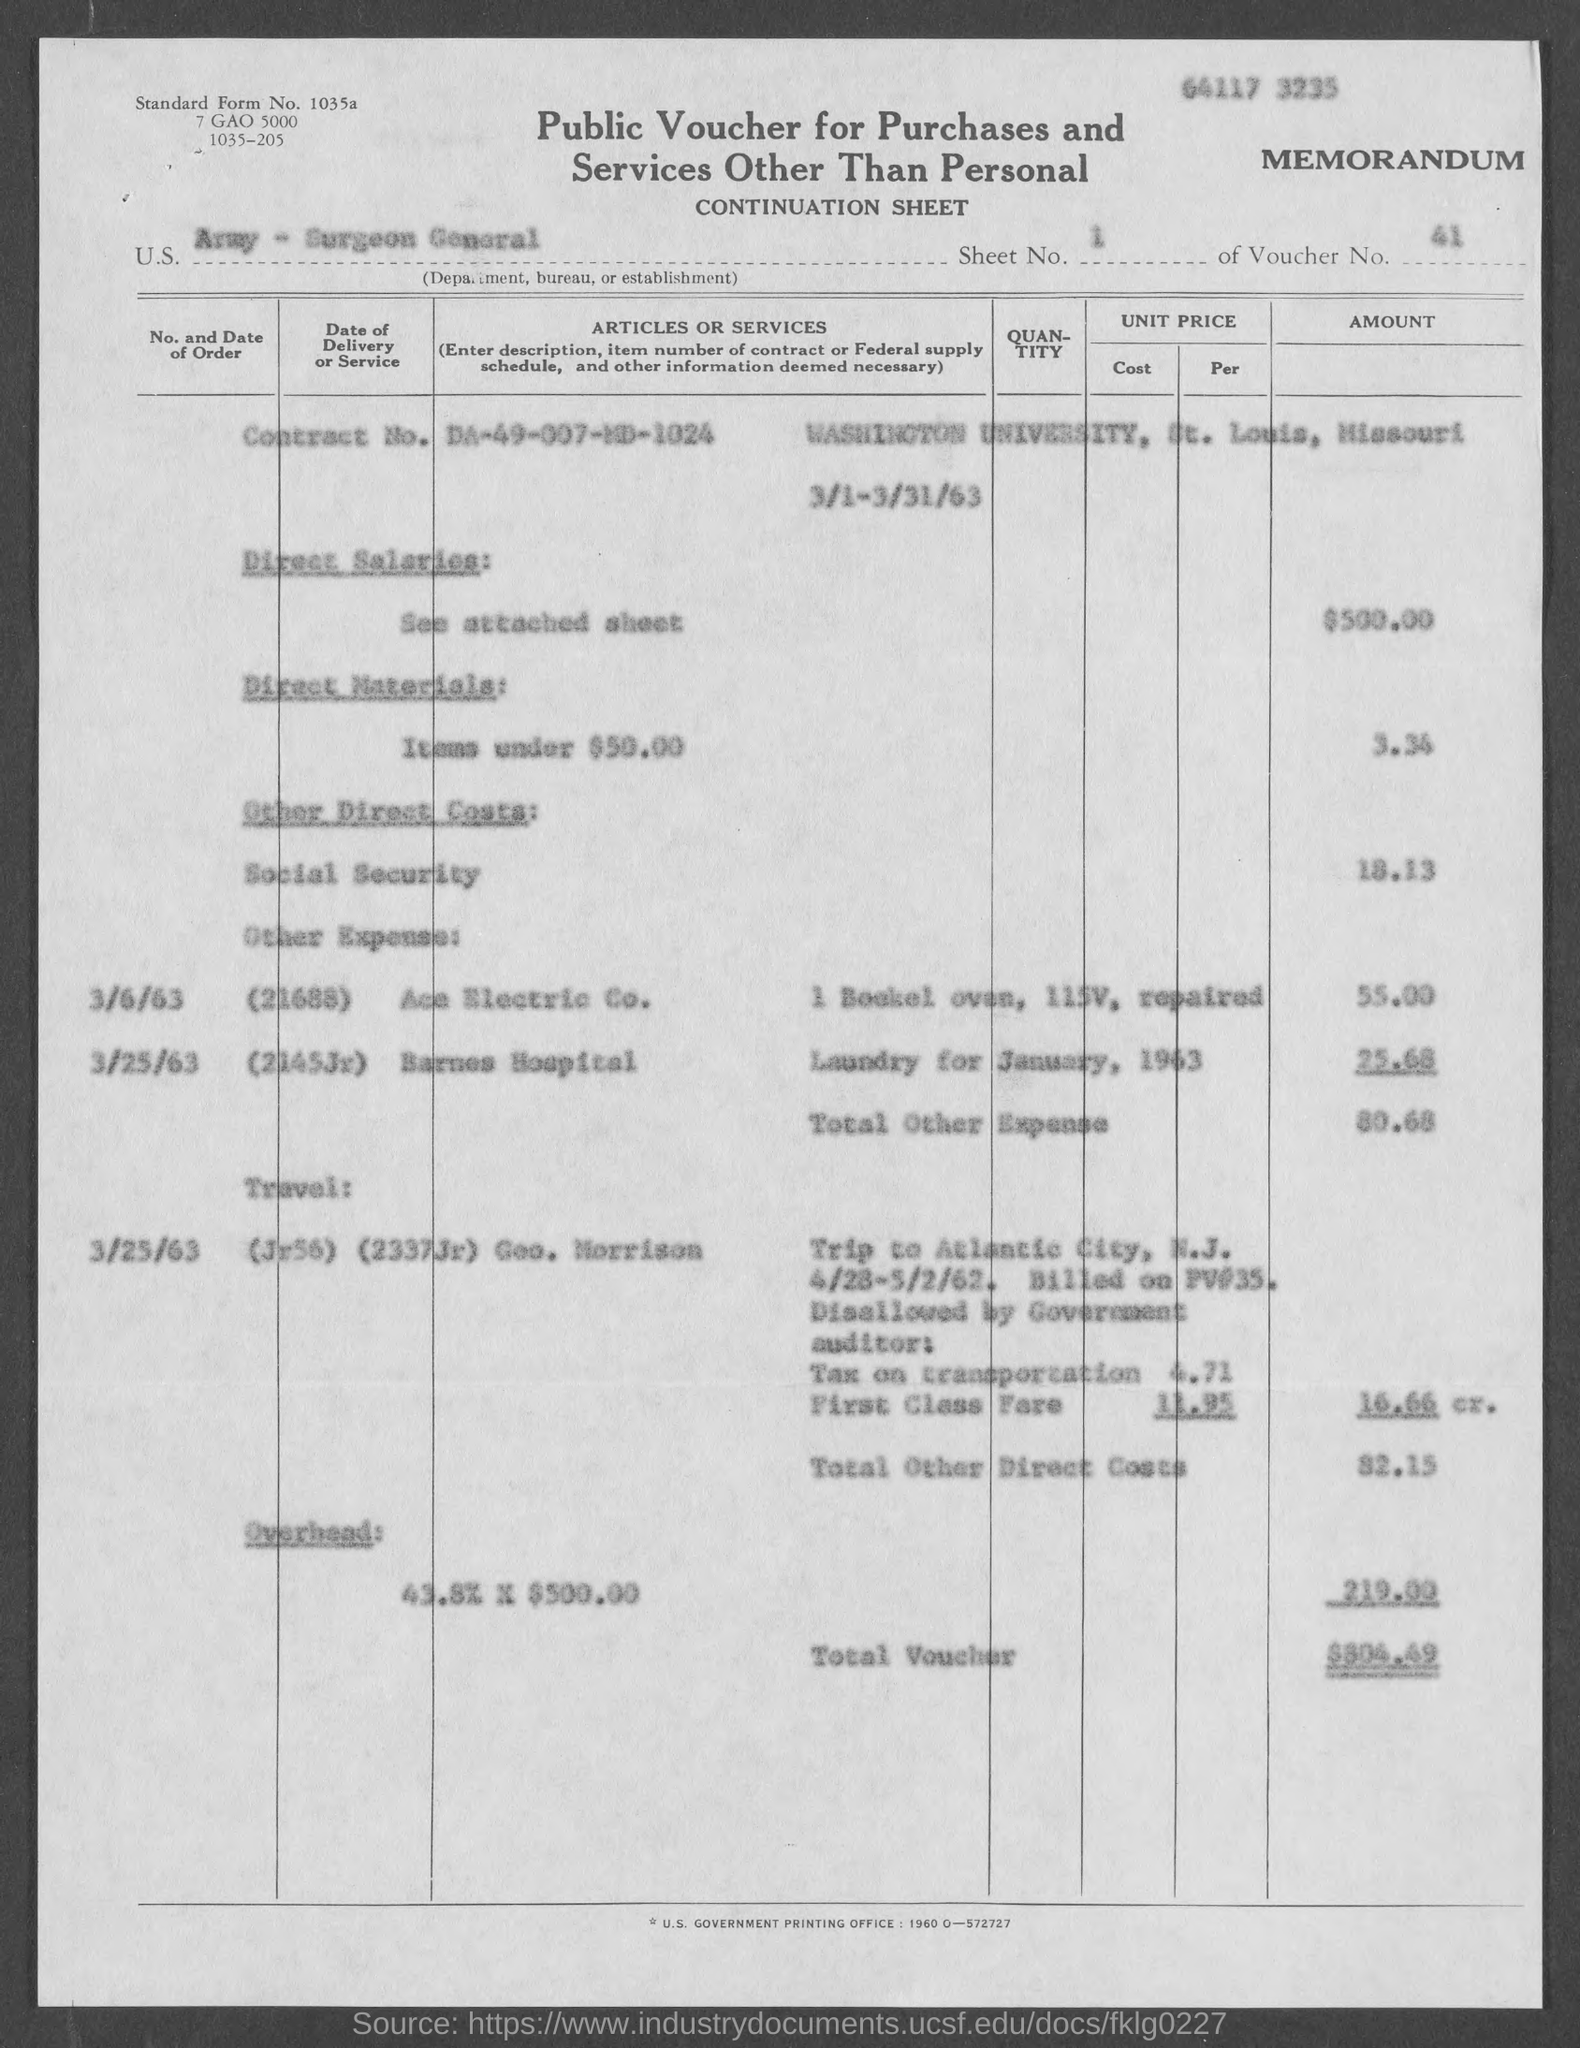What is the Standard Form No. given in the voucher?
Provide a succinct answer. 1035a. What type of voucher is given here?
Keep it short and to the point. Public Voucher for Purchases and Services other than Personal. What is the U.S. Department, Bureau, or Establishment given in the voucher?
Ensure brevity in your answer.  Army - surgeon general. What is the Sheet No. mentioned in the voucher?
Your answer should be very brief. 1. What is the voucher number given in the document?
Your answer should be very brief. 41. What is the direct salaries cost mentioned in the voucher?
Give a very brief answer. $500. 